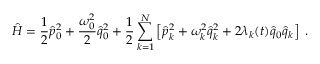<formula> <loc_0><loc_0><loc_500><loc_500>\hat { H } = \frac { 1 } { 2 } \hat { p } _ { 0 } ^ { 2 } + \frac { \omega _ { 0 } ^ { 2 } } { 2 } \hat { q } _ { 0 } ^ { 2 } + \frac { 1 } { 2 } \sum _ { k = 1 } ^ { N } \left [ \hat { p } _ { k } ^ { 2 } + \omega _ { k } ^ { 2 } \hat { q } _ { k } ^ { 2 } + 2 \lambda _ { k } ( t ) \hat { q } _ { 0 } \hat { q } _ { k } \right ] \, .</formula> 